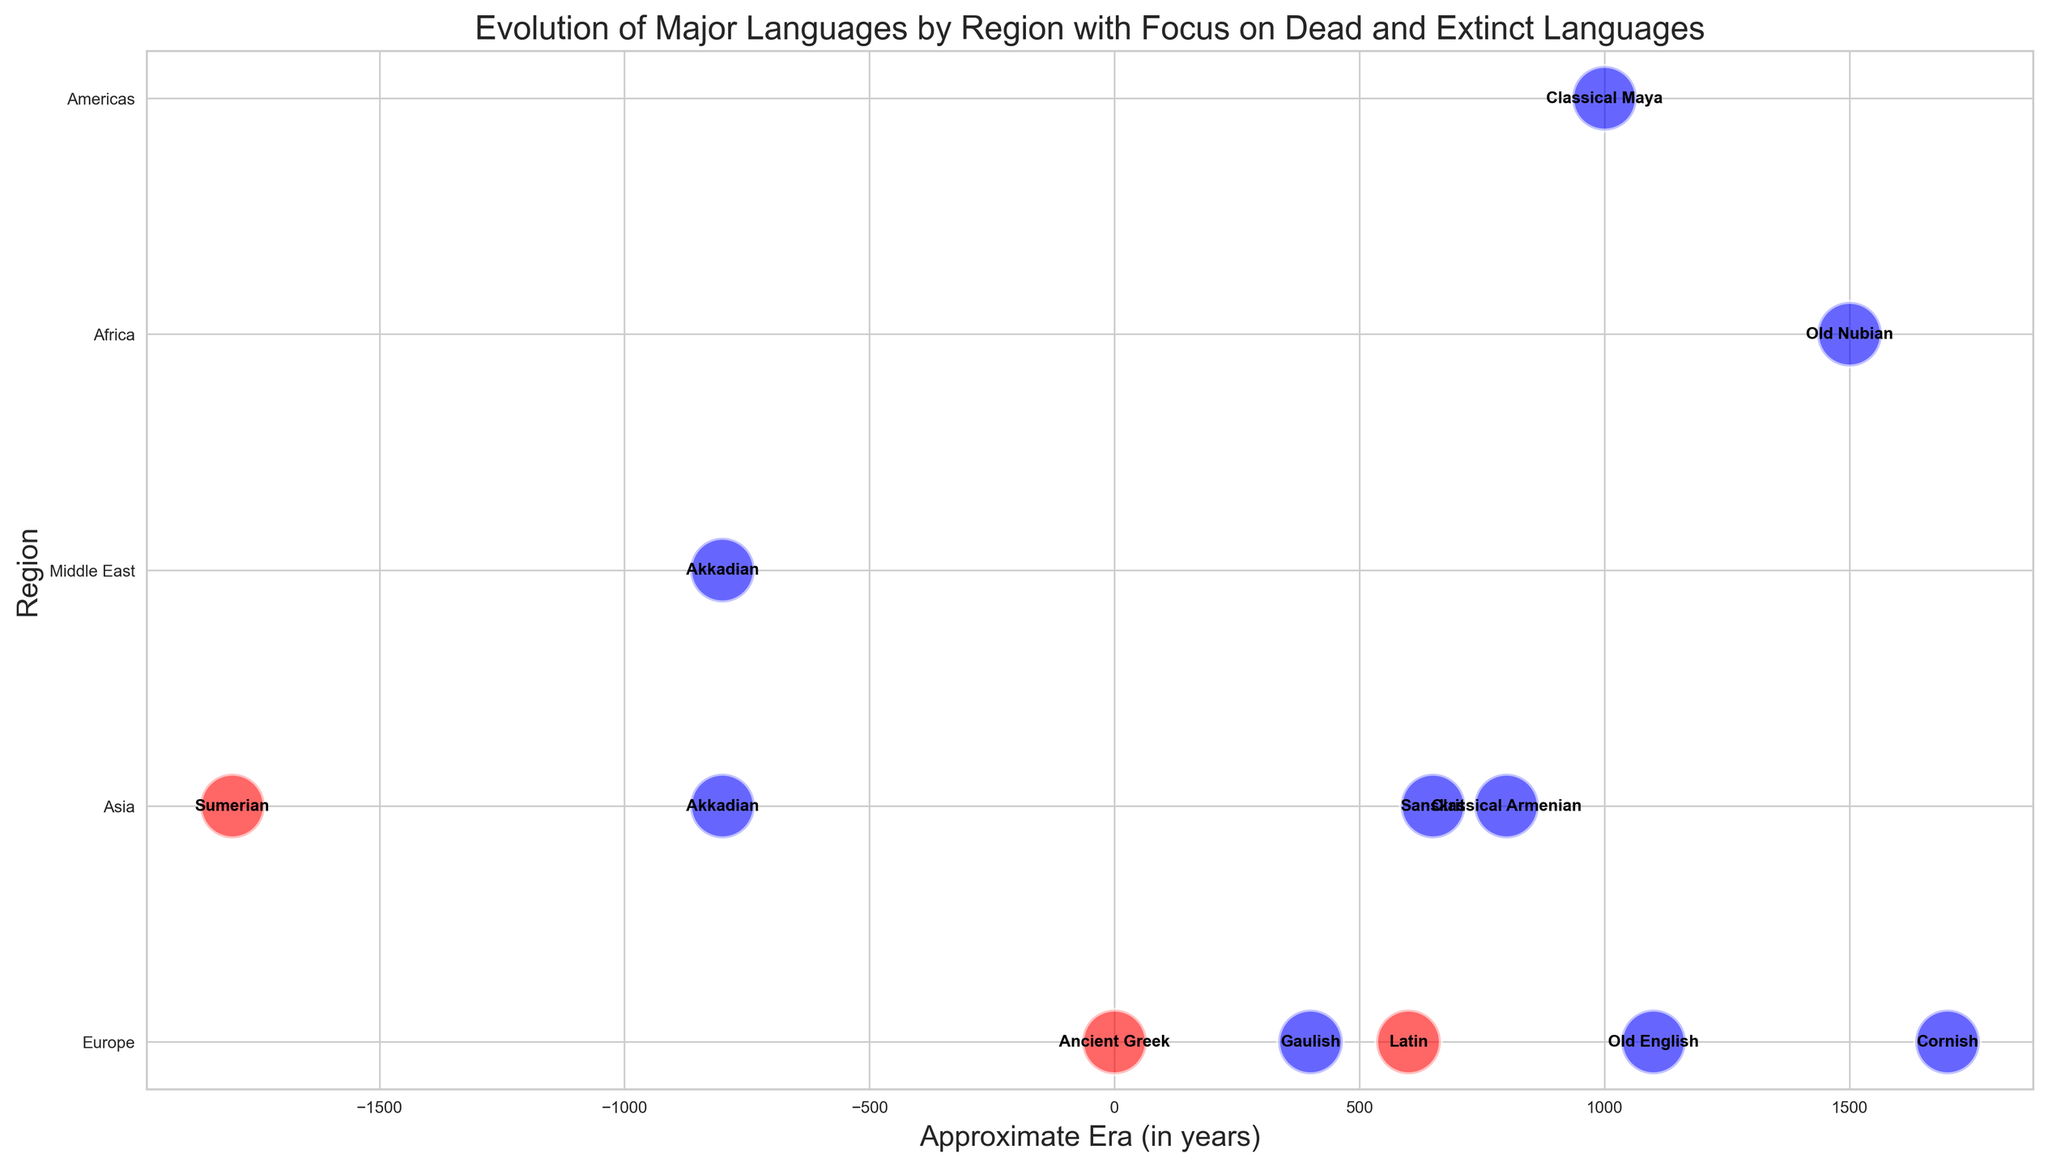What is the approximate era in which Latin died? The bubble representing Latin is located around the 600 mark on the x-axis, indicating the approximate era.
Answer: c. 6th Century AD Which language in the Americas is marked as extinct, and what is its era? The bubble in the Americas region is labeled "Classical Maya" and is positioned around the 1000 mark, which represents the era.
Answer: Classical Maya, c. 10th Century AD Compare the era of the death of Old English and Classical Armenian. Which one became extinct later? The bubble for Old English is around 1100, and Classical Armenian is around 800. Since 1100 is later than 800, Old English became extinct after Classical Armenian.
Answer: Old English Which region has the most languages marked as extinct in the figure? By counting the bubbles for each region, Europe has four (Old English, Gaulish, Cornish, Classical Armenian), which is the most.
Answer: Europe How many dead languages are there in Asia, and which languages are they? The bubbles in Asia marked in red are Sumerian, indicating one dead language in Asia.
Answer: 1, Sumerian What is the era range for Ancient Greek, and in which region is it found? The bubble labeled Ancient Greek lies within 0 (indicating 600 BC - 600 AD) in the Europe region.
Answer: c. 600 BC - 600 AD, Europe Which language died first, Sumerian or Akkadian in Asia? The bubbles for Sumerian and Akkadian in Asia show Sumerian around -1800 and Akkadian around -800, so Sumerian died first.
Answer: Sumerian Visually, what color represents dead languages, and what color represents extinct languages? Dead languages are represented by red bubbles, while extinct languages are represented by blue bubbles.
Answer: Red for dead, blue for extinct Among the languages listed, which has the most recent extinction date? By looking at the x-axis placement, Cornish, around 1700, is the most recent.
Answer: Cornish, c. 18th Century AD Calculate the average era of extinction for languages in Europe. The European languages and their eras are: Latin (600), Old English (1100), Gaulish (400), Cornish (1700), Ancient Greek (0). The average is calculated as: (600 + 1100 + 400 + 1700 + 0)/5 = 760.
Answer: 760 